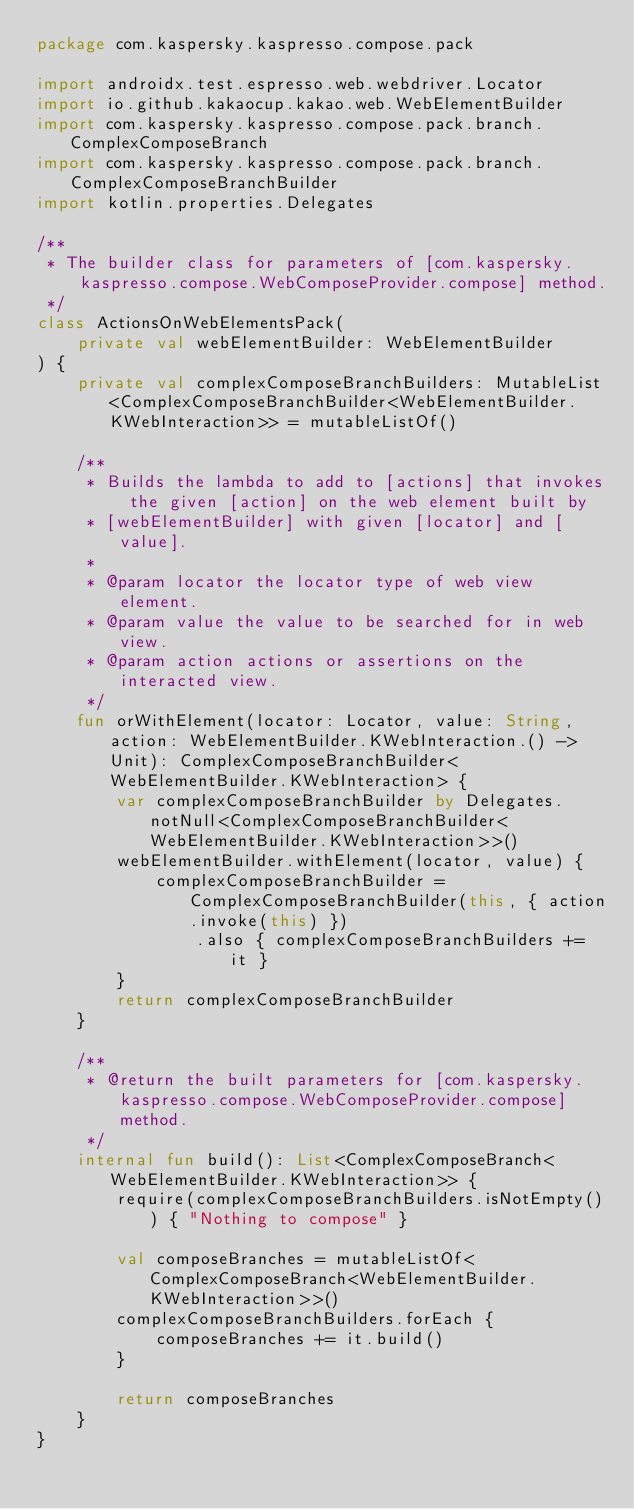Convert code to text. <code><loc_0><loc_0><loc_500><loc_500><_Kotlin_>package com.kaspersky.kaspresso.compose.pack

import androidx.test.espresso.web.webdriver.Locator
import io.github.kakaocup.kakao.web.WebElementBuilder
import com.kaspersky.kaspresso.compose.pack.branch.ComplexComposeBranch
import com.kaspersky.kaspresso.compose.pack.branch.ComplexComposeBranchBuilder
import kotlin.properties.Delegates

/**
 * The builder class for parameters of [com.kaspersky.kaspresso.compose.WebComposeProvider.compose] method.
 */
class ActionsOnWebElementsPack(
    private val webElementBuilder: WebElementBuilder
) {
    private val complexComposeBranchBuilders: MutableList<ComplexComposeBranchBuilder<WebElementBuilder.KWebInteraction>> = mutableListOf()

    /**
     * Builds the lambda to add to [actions] that invokes the given [action] on the web element built by
     * [webElementBuilder] with given [locator] and [value].
     *
     * @param locator the locator type of web view element.
     * @param value the value to be searched for in web view.
     * @param action actions or assertions on the interacted view.
     */
    fun orWithElement(locator: Locator, value: String, action: WebElementBuilder.KWebInteraction.() -> Unit): ComplexComposeBranchBuilder<WebElementBuilder.KWebInteraction> {
        var complexComposeBranchBuilder by Delegates.notNull<ComplexComposeBranchBuilder<WebElementBuilder.KWebInteraction>>()
        webElementBuilder.withElement(locator, value) {
            complexComposeBranchBuilder = ComplexComposeBranchBuilder(this, { action.invoke(this) })
                .also { complexComposeBranchBuilders += it }
        }
        return complexComposeBranchBuilder
    }

    /**
     * @return the built parameters for [com.kaspersky.kaspresso.compose.WebComposeProvider.compose] method.
     */
    internal fun build(): List<ComplexComposeBranch<WebElementBuilder.KWebInteraction>> {
        require(complexComposeBranchBuilders.isNotEmpty()) { "Nothing to compose" }

        val composeBranches = mutableListOf<ComplexComposeBranch<WebElementBuilder.KWebInteraction>>()
        complexComposeBranchBuilders.forEach {
            composeBranches += it.build()
        }

        return composeBranches
    }
}
</code> 